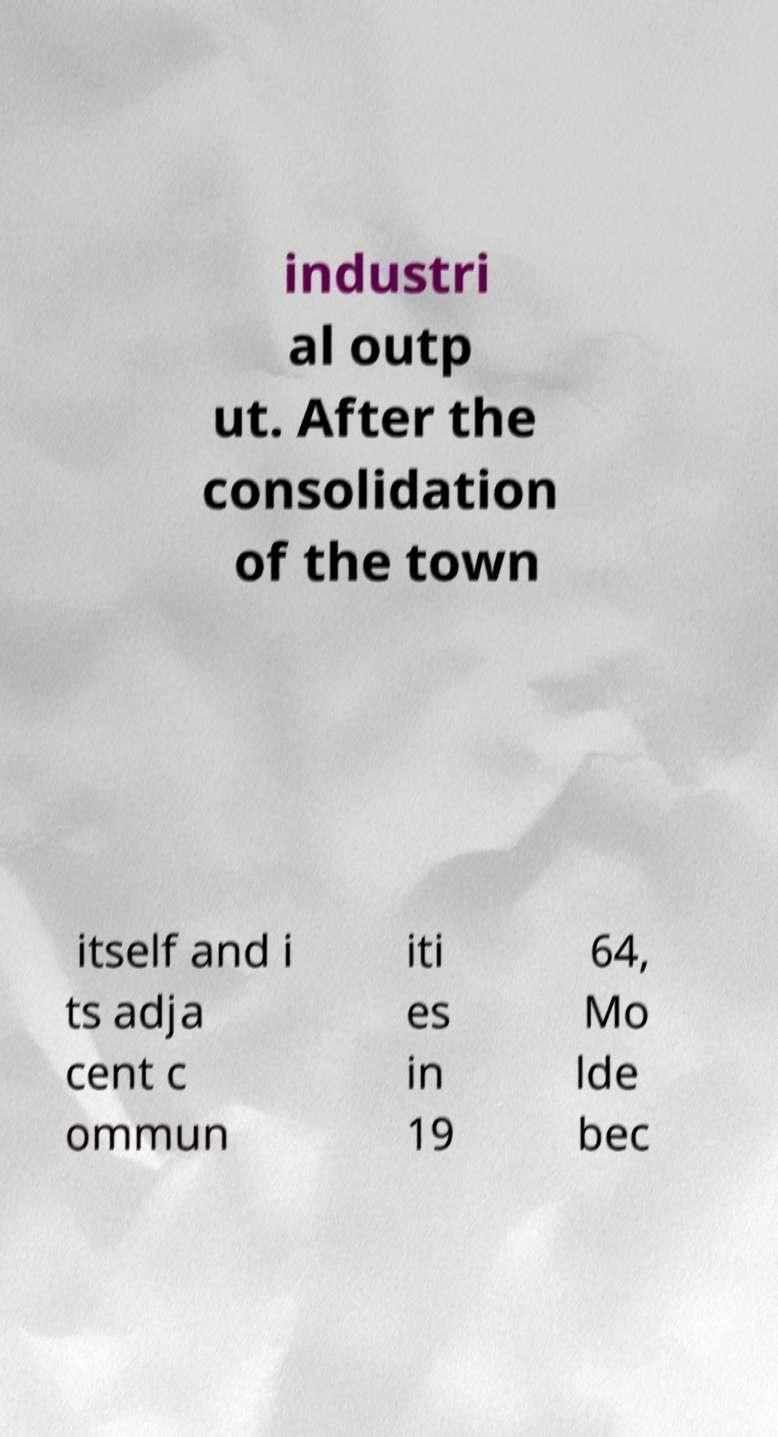There's text embedded in this image that I need extracted. Can you transcribe it verbatim? industri al outp ut. After the consolidation of the town itself and i ts adja cent c ommun iti es in 19 64, Mo lde bec 